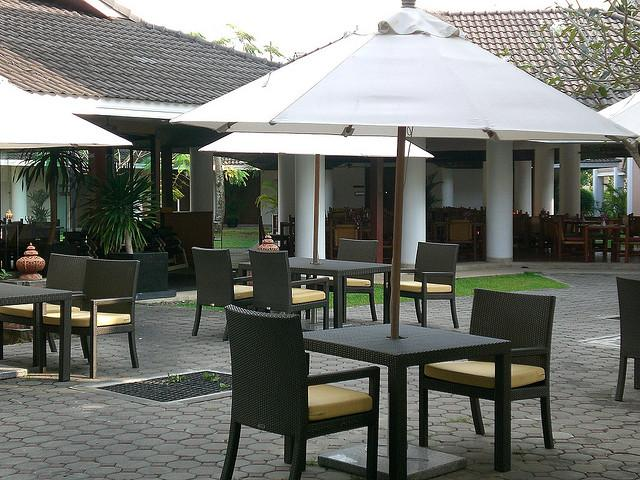What is the purpose of the umbrellas?

Choices:
A) decorative
B) hide people
C) sun protection
D) rain protection sun protection 